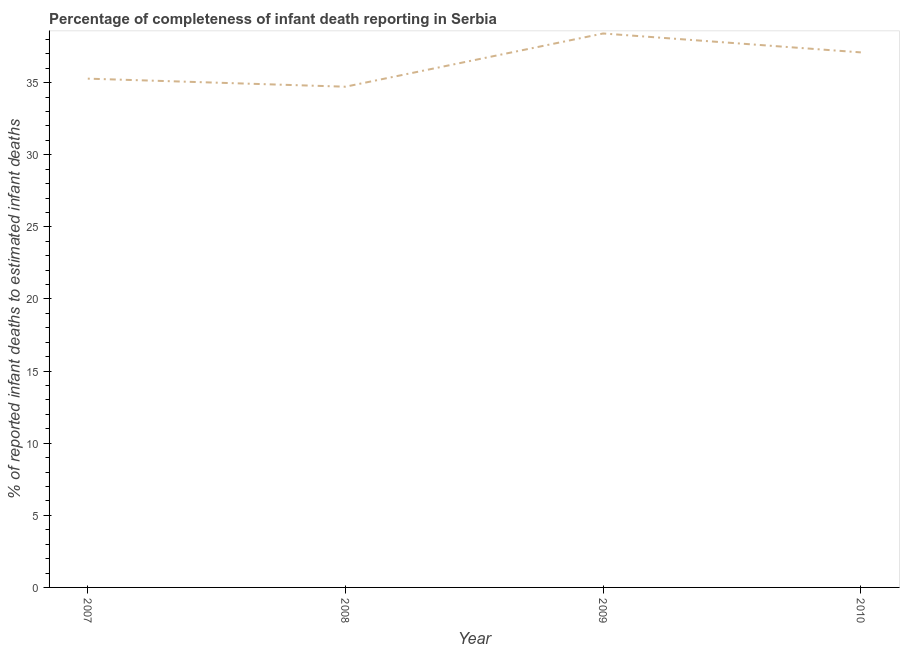What is the completeness of infant death reporting in 2008?
Your answer should be compact. 34.72. Across all years, what is the maximum completeness of infant death reporting?
Keep it short and to the point. 38.41. Across all years, what is the minimum completeness of infant death reporting?
Make the answer very short. 34.72. In which year was the completeness of infant death reporting minimum?
Offer a terse response. 2008. What is the sum of the completeness of infant death reporting?
Your answer should be very brief. 145.5. What is the difference between the completeness of infant death reporting in 2007 and 2009?
Provide a short and direct response. -3.13. What is the average completeness of infant death reporting per year?
Your answer should be very brief. 36.37. What is the median completeness of infant death reporting?
Keep it short and to the point. 36.19. In how many years, is the completeness of infant death reporting greater than 4 %?
Provide a succinct answer. 4. What is the ratio of the completeness of infant death reporting in 2007 to that in 2008?
Your response must be concise. 1.02. What is the difference between the highest and the second highest completeness of infant death reporting?
Your answer should be very brief. 1.31. Is the sum of the completeness of infant death reporting in 2008 and 2010 greater than the maximum completeness of infant death reporting across all years?
Make the answer very short. Yes. What is the difference between the highest and the lowest completeness of infant death reporting?
Your answer should be compact. 3.69. In how many years, is the completeness of infant death reporting greater than the average completeness of infant death reporting taken over all years?
Offer a very short reply. 2. How many years are there in the graph?
Offer a very short reply. 4. Are the values on the major ticks of Y-axis written in scientific E-notation?
Your answer should be compact. No. Does the graph contain any zero values?
Your answer should be very brief. No. Does the graph contain grids?
Your answer should be compact. No. What is the title of the graph?
Your answer should be very brief. Percentage of completeness of infant death reporting in Serbia. What is the label or title of the Y-axis?
Make the answer very short. % of reported infant deaths to estimated infant deaths. What is the % of reported infant deaths to estimated infant deaths of 2007?
Your answer should be very brief. 35.28. What is the % of reported infant deaths to estimated infant deaths in 2008?
Offer a terse response. 34.72. What is the % of reported infant deaths to estimated infant deaths of 2009?
Provide a short and direct response. 38.41. What is the % of reported infant deaths to estimated infant deaths of 2010?
Provide a short and direct response. 37.1. What is the difference between the % of reported infant deaths to estimated infant deaths in 2007 and 2008?
Give a very brief answer. 0.56. What is the difference between the % of reported infant deaths to estimated infant deaths in 2007 and 2009?
Offer a very short reply. -3.13. What is the difference between the % of reported infant deaths to estimated infant deaths in 2007 and 2010?
Make the answer very short. -1.82. What is the difference between the % of reported infant deaths to estimated infant deaths in 2008 and 2009?
Offer a terse response. -3.69. What is the difference between the % of reported infant deaths to estimated infant deaths in 2008 and 2010?
Your response must be concise. -2.38. What is the difference between the % of reported infant deaths to estimated infant deaths in 2009 and 2010?
Offer a very short reply. 1.31. What is the ratio of the % of reported infant deaths to estimated infant deaths in 2007 to that in 2008?
Your answer should be very brief. 1.02. What is the ratio of the % of reported infant deaths to estimated infant deaths in 2007 to that in 2009?
Give a very brief answer. 0.92. What is the ratio of the % of reported infant deaths to estimated infant deaths in 2007 to that in 2010?
Your answer should be very brief. 0.95. What is the ratio of the % of reported infant deaths to estimated infant deaths in 2008 to that in 2009?
Provide a short and direct response. 0.9. What is the ratio of the % of reported infant deaths to estimated infant deaths in 2008 to that in 2010?
Keep it short and to the point. 0.94. What is the ratio of the % of reported infant deaths to estimated infant deaths in 2009 to that in 2010?
Offer a terse response. 1.03. 